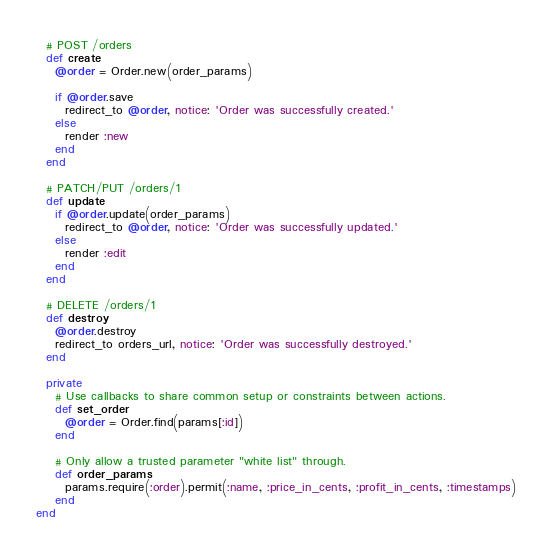<code> <loc_0><loc_0><loc_500><loc_500><_Ruby_>
  # POST /orders
  def create
    @order = Order.new(order_params)

    if @order.save
      redirect_to @order, notice: 'Order was successfully created.'
    else
      render :new
    end
  end

  # PATCH/PUT /orders/1
  def update
    if @order.update(order_params)
      redirect_to @order, notice: 'Order was successfully updated.'
    else
      render :edit
    end
  end

  # DELETE /orders/1
  def destroy
    @order.destroy
    redirect_to orders_url, notice: 'Order was successfully destroyed.'
  end

  private
    # Use callbacks to share common setup or constraints between actions.
    def set_order
      @order = Order.find(params[:id])
    end

    # Only allow a trusted parameter "white list" through.
    def order_params
      params.require(:order).permit(:name, :price_in_cents, :profit_in_cents, :timestamps)
    end
end
</code> 